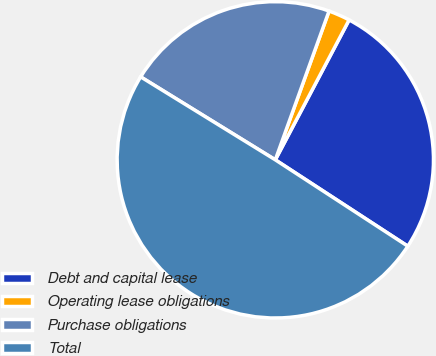Convert chart. <chart><loc_0><loc_0><loc_500><loc_500><pie_chart><fcel>Debt and capital lease<fcel>Operating lease obligations<fcel>Purchase obligations<fcel>Total<nl><fcel>26.47%<fcel>2.21%<fcel>21.73%<fcel>49.6%<nl></chart> 